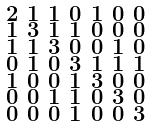Convert formula to latex. <formula><loc_0><loc_0><loc_500><loc_500>\begin{smallmatrix} 2 & 1 & 1 & 0 & 1 & 0 & 0 \\ 1 & 3 & 1 & 1 & 0 & 0 & 0 \\ 1 & 1 & 3 & 0 & 0 & 1 & 0 \\ 0 & 1 & 0 & 3 & 1 & 1 & 1 \\ 1 & 0 & 0 & 1 & 3 & 0 & 0 \\ 0 & 0 & 1 & 1 & 0 & 3 & 0 \\ 0 & 0 & 0 & 1 & 0 & 0 & 3 \end{smallmatrix}</formula> 